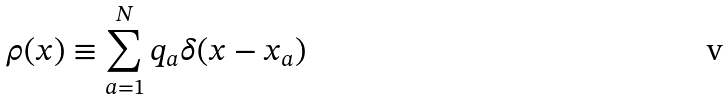Convert formula to latex. <formula><loc_0><loc_0><loc_500><loc_500>\rho ( x ) \equiv \sum _ { a = 1 } ^ { N } q _ { a } \delta ( x - x _ { a } )</formula> 